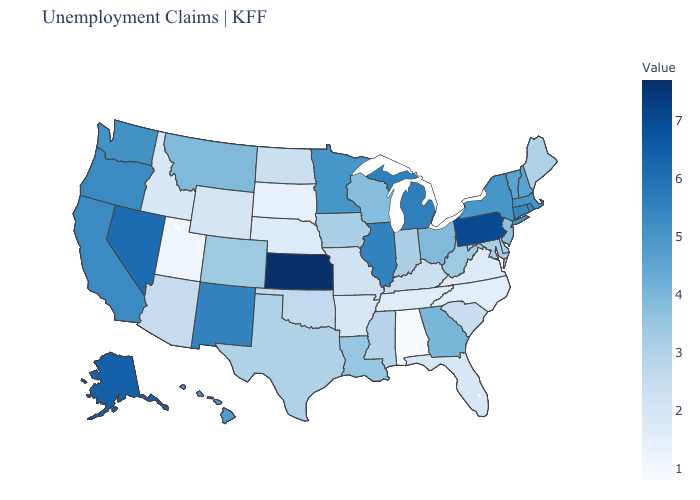Does Alabama have the lowest value in the USA?
Concise answer only. Yes. Does Alabama have the lowest value in the USA?
Quick response, please. Yes. Does Kansas have the highest value in the USA?
Write a very short answer. Yes. Which states have the highest value in the USA?
Concise answer only. Kansas. Among the states that border Delaware , which have the highest value?
Concise answer only. Pennsylvania. Which states have the lowest value in the USA?
Concise answer only. Alabama. 